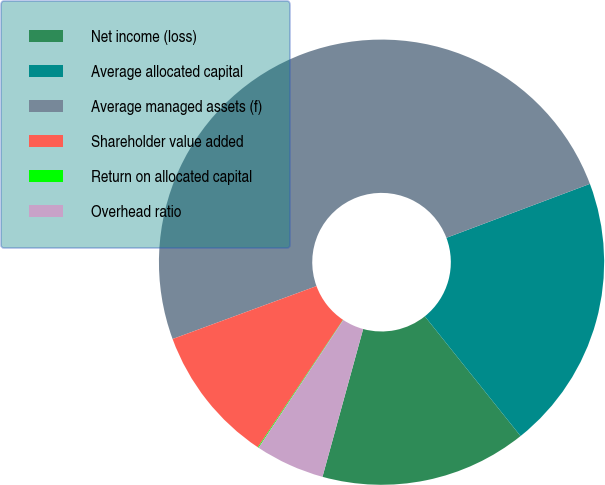Convert chart. <chart><loc_0><loc_0><loc_500><loc_500><pie_chart><fcel>Net income (loss)<fcel>Average allocated capital<fcel>Average managed assets (f)<fcel>Shareholder value added<fcel>Return on allocated capital<fcel>Overhead ratio<nl><fcel>15.01%<fcel>19.99%<fcel>49.89%<fcel>10.02%<fcel>0.06%<fcel>5.04%<nl></chart> 